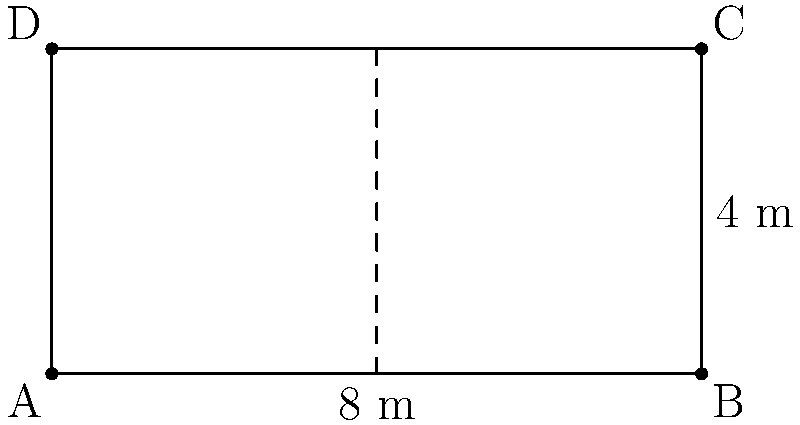In a government office, there's a rectangular conference table with dimensions 8 meters by 4 meters. If sensitive documents covering an area of 20 square meters are spread out on the table, what percentage of the table's surface area remains uncovered? To solve this problem, let's follow these steps:

1. Calculate the total area of the conference table:
   Area = length × width
   $$A = 8 \text{ m} \times 4 \text{ m} = 32 \text{ m}^2$$

2. Determine the uncovered area:
   Uncovered area = Total area - Covered area
   $$U = 32 \text{ m}^2 - 20 \text{ m}^2 = 12 \text{ m}^2$$

3. Calculate the percentage of uncovered area:
   Percentage = (Uncovered area ÷ Total area) × 100
   $$P = \frac{12 \text{ m}^2}{32 \text{ m}^2} \times 100 = 0.375 \times 100 = 37.5\%$$

Therefore, 37.5% of the table's surface area remains uncovered.
Answer: 37.5% 